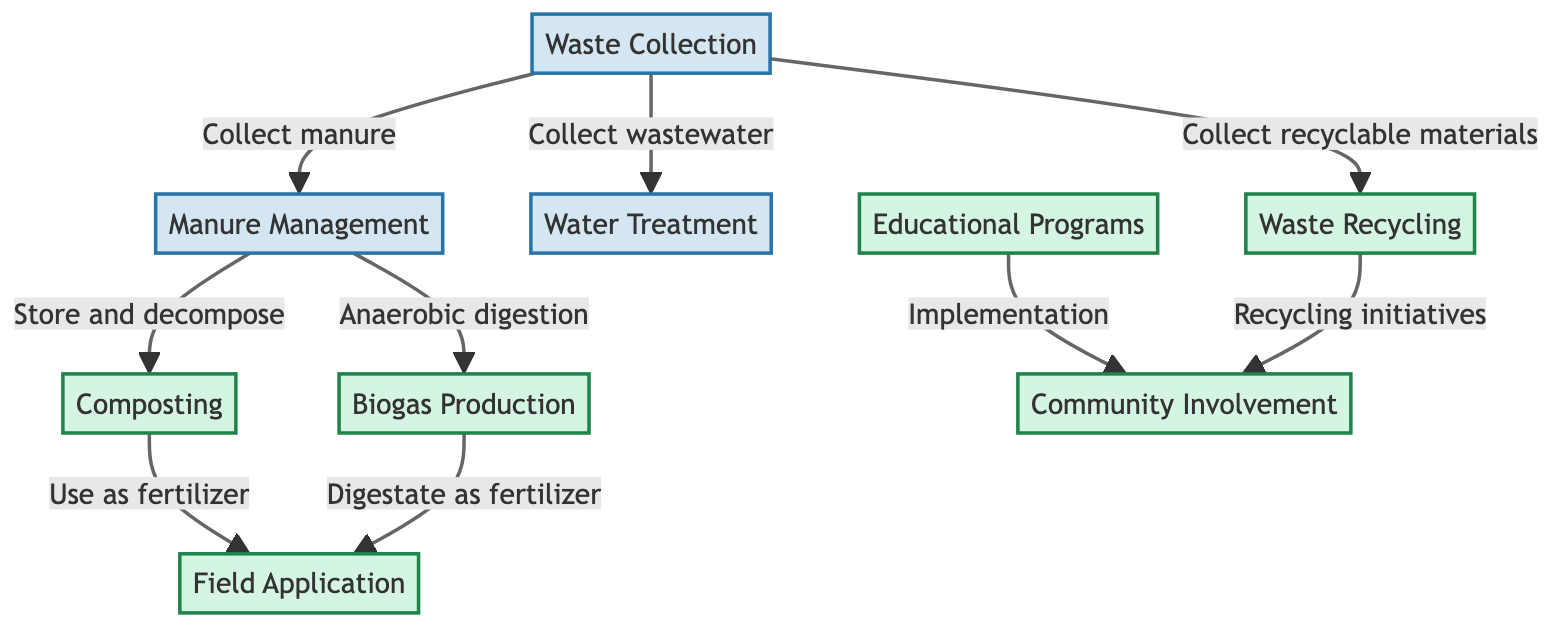What is the first process in the waste management flowchart? The first process is Waste Collection, as it is the starting point before any other processing occurs.
Answer: Waste Collection How many sustainable practices are implemented in the diagram? The diagram lists a total of five sustainable practices: Composting, Biogas Production, Field Application, Waste Recycling, and Educational Programs.
Answer: 5 Which process is associated with the treatment of wastewater? The process associated with the treatment of wastewater is Water Treatment, as indicated by the directed flow from Waste Collection to Water Treatment.
Answer: Water Treatment What is produced through Anaerobic digestion? Anaerobic digestion produces Biogas, as shown in the diagram where it is connected to Manure Management.
Answer: Biogas What is the relationship between Composting and Field Application? The relationship is that Composting is used as fertilizer for Field Application, demonstrating a sustainable practice of reusing organic waste.
Answer: Use as fertilizer What flows into Community Involvement? Community Involvement receives inputs from Educational Programs and Waste Recycling, indicating that both initiatives promote community engagement in sustainability.
Answer: Educational Programs, Waste Recycling What action follows Biogas Production? Following Biogas Production, the flow goes to Field Application, where the digestate is used as fertilizer, completing the cycle of waste management.
Answer: Digestate as fertilizer Which process collects recyclable materials? The process that collects recyclable materials is Waste Recycling, which diverts recyclables from waste streams for proper management.
Answer: Waste Recycling Name one benefit of implementing Educational Programs. One benefit is that they enhance Community Involvement by encouraging participation in waste management practices and sustainability efforts.
Answer: Community Involvement 